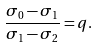Convert formula to latex. <formula><loc_0><loc_0><loc_500><loc_500>\frac { \sigma _ { 0 } - \sigma _ { 1 } } { \sigma _ { 1 } - \sigma _ { 2 } } = q .</formula> 